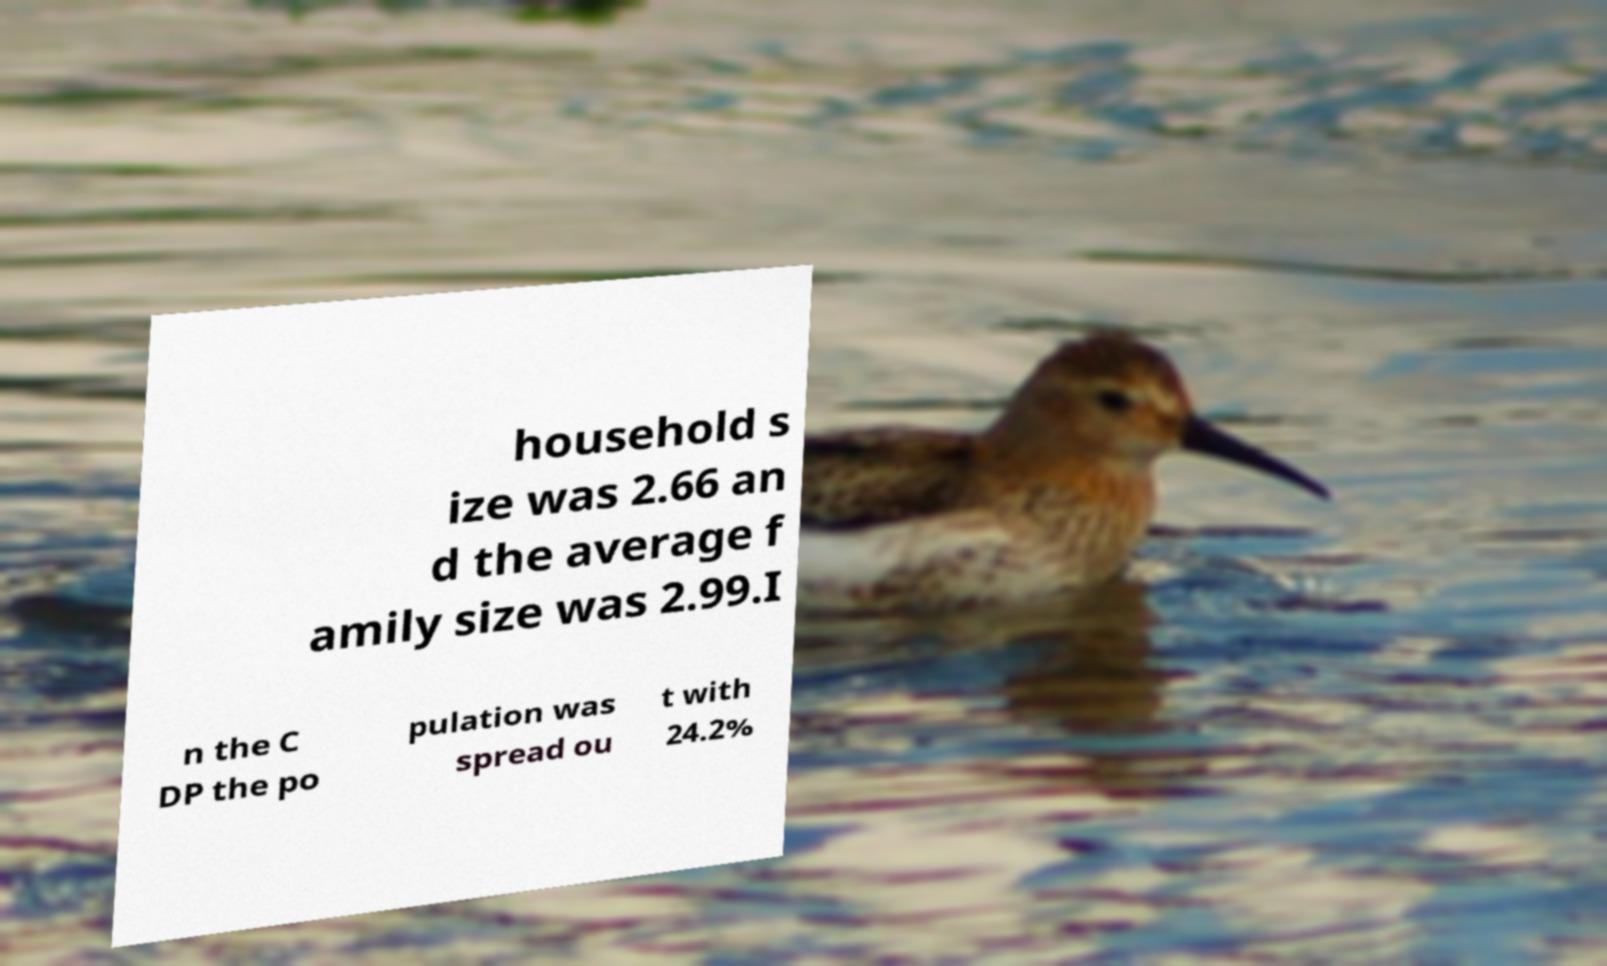Could you assist in decoding the text presented in this image and type it out clearly? household s ize was 2.66 an d the average f amily size was 2.99.I n the C DP the po pulation was spread ou t with 24.2% 